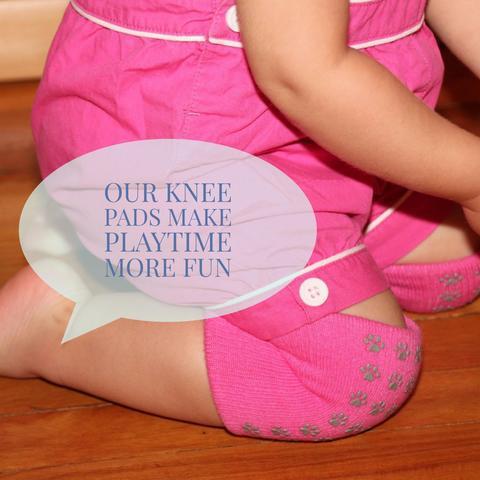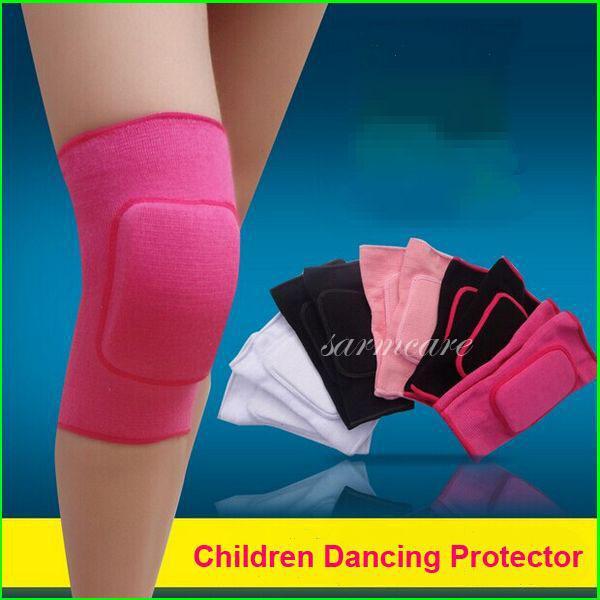The first image is the image on the left, the second image is the image on the right. Considering the images on both sides, is "One image shows a pair of toddler knees kneeling on a wood floor and wearing colored knee pads with paw prints on them." valid? Answer yes or no. Yes. The first image is the image on the left, the second image is the image on the right. For the images displayed, is the sentence "The left and right image contains the same number of soft knit wrist guards." factually correct? Answer yes or no. No. 